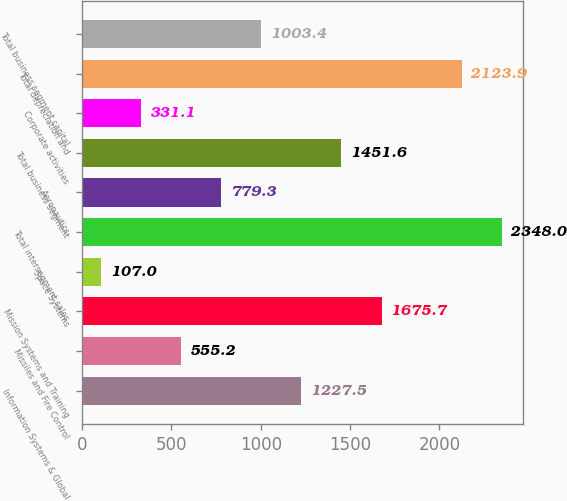Convert chart. <chart><loc_0><loc_0><loc_500><loc_500><bar_chart><fcel>Information Systems & Global<fcel>Missiles and Fire Control<fcel>Mission Systems and Training<fcel>Space Systems<fcel>Total intersegment sales<fcel>Aeronautics<fcel>Total business segment<fcel>Corporate activities<fcel>Total depreciation and<fcel>Total business segment capital<nl><fcel>1227.5<fcel>555.2<fcel>1675.7<fcel>107<fcel>2348<fcel>779.3<fcel>1451.6<fcel>331.1<fcel>2123.9<fcel>1003.4<nl></chart> 